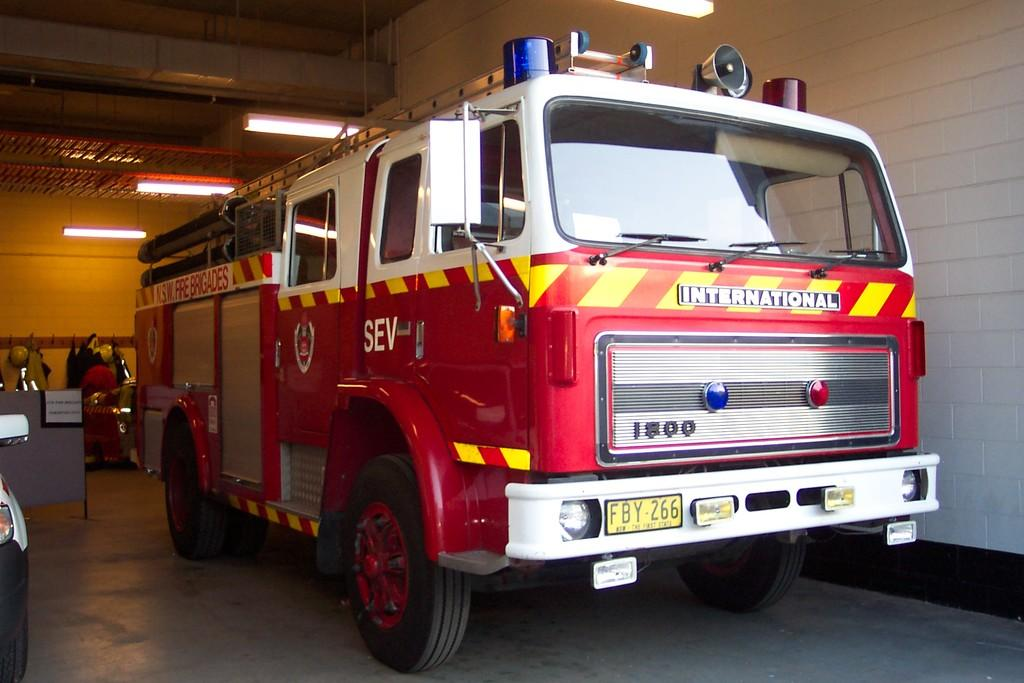What type of vehicle is in the image? There is a red color bus in the image. Where is the bus located in the image? The bus is visible on the floor. What other objects can be seen in the image? There are lights in the image. What is the background of the image? There is a wall in the image. Can you tell me how many goats are standing next to the bus in the image? There are no goats present in the image; it only features a red color bus on the floor. What memory does the bus in the image evoke for you? The image does not evoke any personal memories, as it only contains a red color bus on the floor, lights, and a wall. 